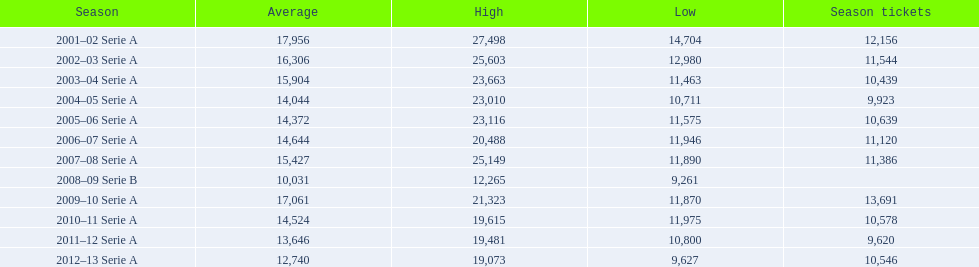What are the seasons? 2001–02 Serie A, 2002–03 Serie A, 2003–04 Serie A, 2004–05 Serie A, 2005–06 Serie A, 2006–07 Serie A, 2007–08 Serie A, 2008–09 Serie B, 2009–10 Serie A, 2010–11 Serie A, 2011–12 Serie A, 2012–13 Serie A. Which season is in 2007? 2007–08 Serie A. How many season tickets were sold that season? 11,386. 